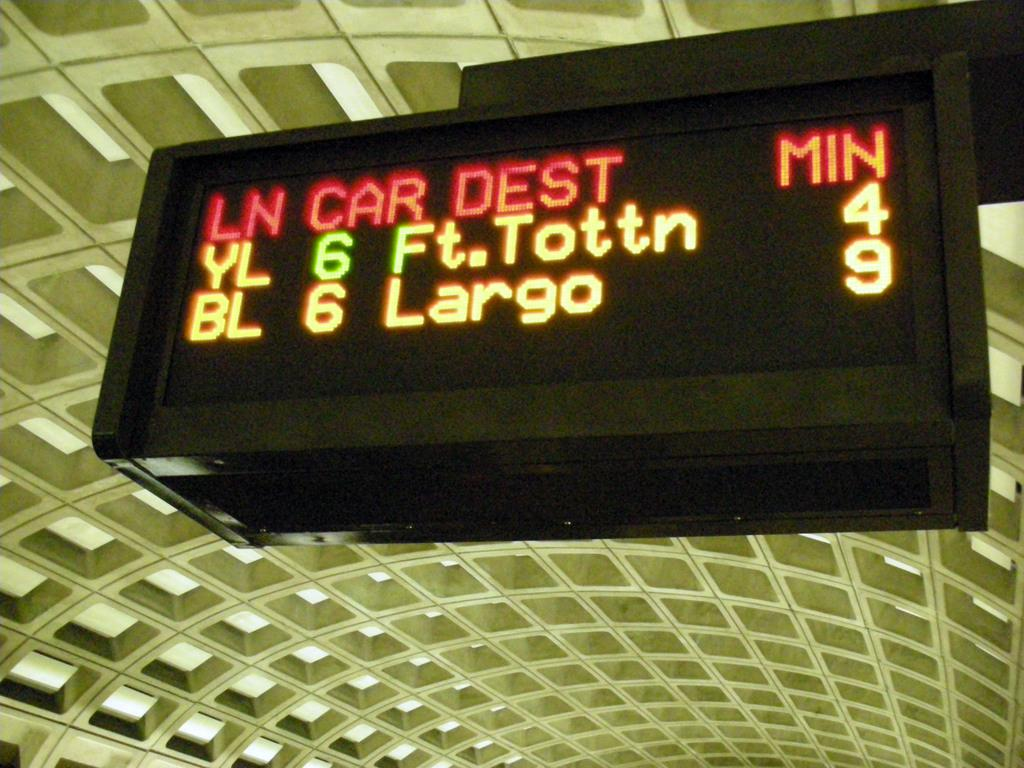Provide a one-sentence caption for the provided image. The train station shows the times of new trains coming into the station. 